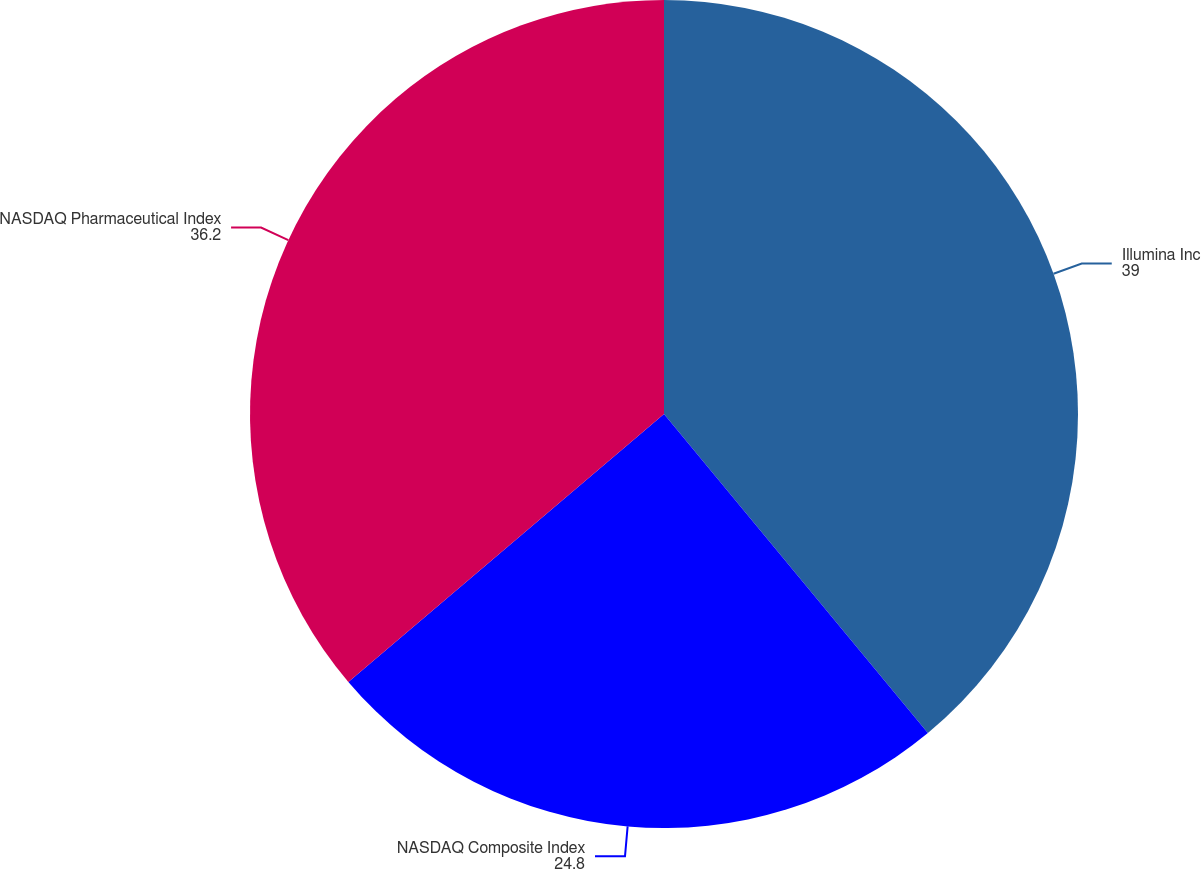<chart> <loc_0><loc_0><loc_500><loc_500><pie_chart><fcel>Illumina Inc<fcel>NASDAQ Composite Index<fcel>NASDAQ Pharmaceutical Index<nl><fcel>39.0%<fcel>24.8%<fcel>36.2%<nl></chart> 